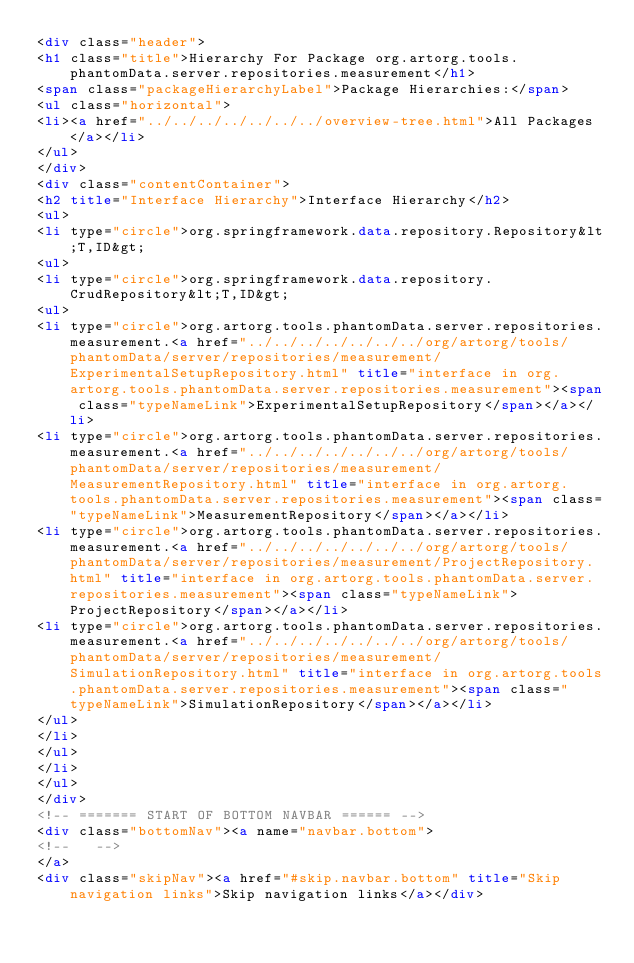<code> <loc_0><loc_0><loc_500><loc_500><_HTML_><div class="header">
<h1 class="title">Hierarchy For Package org.artorg.tools.phantomData.server.repositories.measurement</h1>
<span class="packageHierarchyLabel">Package Hierarchies:</span>
<ul class="horizontal">
<li><a href="../../../../../../../overview-tree.html">All Packages</a></li>
</ul>
</div>
<div class="contentContainer">
<h2 title="Interface Hierarchy">Interface Hierarchy</h2>
<ul>
<li type="circle">org.springframework.data.repository.Repository&lt;T,ID&gt;
<ul>
<li type="circle">org.springframework.data.repository.CrudRepository&lt;T,ID&gt;
<ul>
<li type="circle">org.artorg.tools.phantomData.server.repositories.measurement.<a href="../../../../../../../org/artorg/tools/phantomData/server/repositories/measurement/ExperimentalSetupRepository.html" title="interface in org.artorg.tools.phantomData.server.repositories.measurement"><span class="typeNameLink">ExperimentalSetupRepository</span></a></li>
<li type="circle">org.artorg.tools.phantomData.server.repositories.measurement.<a href="../../../../../../../org/artorg/tools/phantomData/server/repositories/measurement/MeasurementRepository.html" title="interface in org.artorg.tools.phantomData.server.repositories.measurement"><span class="typeNameLink">MeasurementRepository</span></a></li>
<li type="circle">org.artorg.tools.phantomData.server.repositories.measurement.<a href="../../../../../../../org/artorg/tools/phantomData/server/repositories/measurement/ProjectRepository.html" title="interface in org.artorg.tools.phantomData.server.repositories.measurement"><span class="typeNameLink">ProjectRepository</span></a></li>
<li type="circle">org.artorg.tools.phantomData.server.repositories.measurement.<a href="../../../../../../../org/artorg/tools/phantomData/server/repositories/measurement/SimulationRepository.html" title="interface in org.artorg.tools.phantomData.server.repositories.measurement"><span class="typeNameLink">SimulationRepository</span></a></li>
</ul>
</li>
</ul>
</li>
</ul>
</div>
<!-- ======= START OF BOTTOM NAVBAR ====== -->
<div class="bottomNav"><a name="navbar.bottom">
<!--   -->
</a>
<div class="skipNav"><a href="#skip.navbar.bottom" title="Skip navigation links">Skip navigation links</a></div></code> 